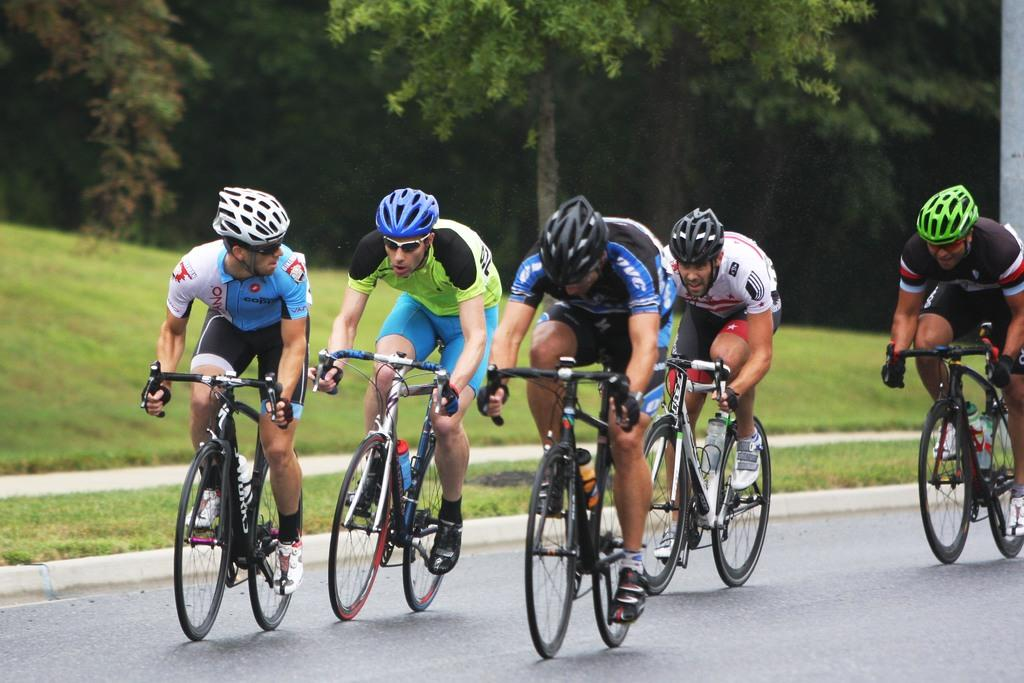What are the men in the image doing? The men in the image are cycling bicycles. What safety precaution are the men taking while cycling? The men are wearing helmets. What is the setting of the image? There is a road in the image, and trees can be seen in the background. What type of juice is being served by the servant in the background? There is no servant or juice present in the image. What trick are the men performing while cycling? There is no trick being performed by the men while cycling; they are simply riding their bicycles. 